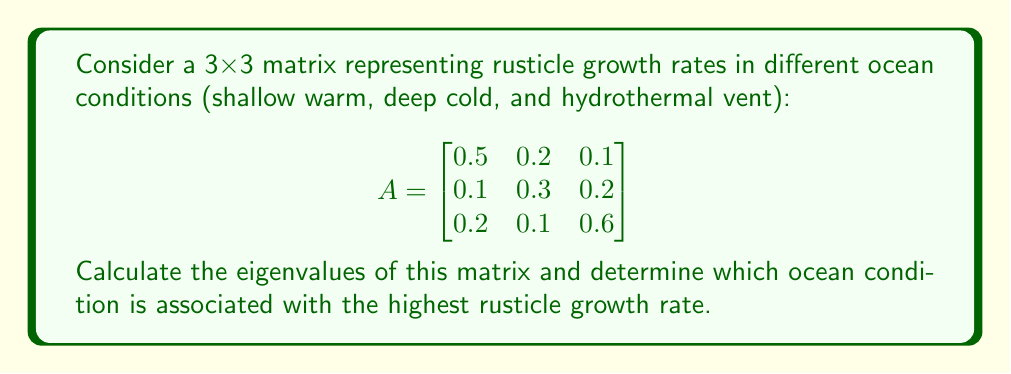Teach me how to tackle this problem. To find the eigenvalues of matrix A, we need to solve the characteristic equation:

$$\det(A - \lambda I) = 0$$

Where $I$ is the 3x3 identity matrix and $\lambda$ represents the eigenvalues.

Step 1: Set up the characteristic equation
$$\det\begin{pmatrix}
0.5-\lambda & 0.2 & 0.1 \\
0.1 & 0.3-\lambda & 0.2 \\
0.2 & 0.1 & 0.6-\lambda
\end{pmatrix} = 0$$

Step 2: Expand the determinant
$$(0.5-\lambda)[(0.3-\lambda)(0.6-\lambda)-0.02] - 0.2[0.1(0.6-\lambda)-0.02] + 0.1[0.1(0.3-\lambda)-0.02] = 0$$

Step 3: Simplify
$$-\lambda^3 + 1.4\lambda^2 - 0.47\lambda + 0.048 = 0$$

Step 4: Solve the cubic equation
Using a cubic equation solver or numerical methods, we find the roots:

$$\lambda_1 \approx 0.7816$$
$$\lambda_2 \approx 0.3592$$
$$\lambda_3 \approx 0.2592$$

Step 5: Interpret the results
The eigenvalues represent the growth rates in different ocean conditions. The largest eigenvalue ($\lambda_1 \approx 0.7816$) corresponds to the highest rusticle growth rate.

Since the matrix rows represent shallow warm, deep cold, and hydrothermal vent conditions respectively, we can associate the largest eigenvalue with the third row, which represents the hydrothermal vent condition.
Answer: Eigenvalues: 0.7816, 0.3592, 0.2592; Highest growth rate: Hydrothermal vent condition 